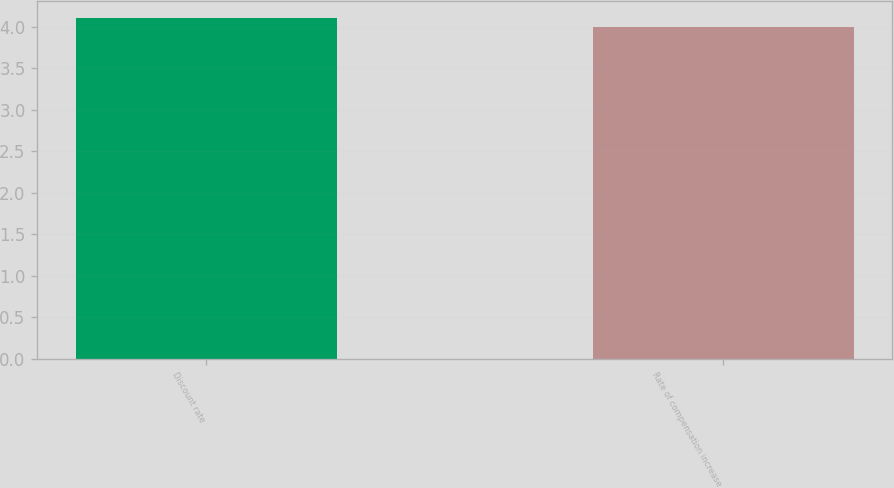Convert chart to OTSL. <chart><loc_0><loc_0><loc_500><loc_500><bar_chart><fcel>Discount rate<fcel>Rate of compensation increase<nl><fcel>4.1<fcel>4<nl></chart> 